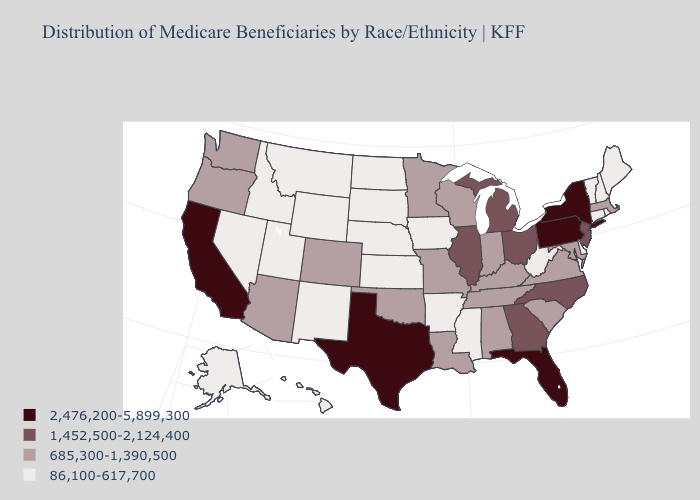Name the states that have a value in the range 86,100-617,700?
Write a very short answer. Alaska, Arkansas, Connecticut, Delaware, Hawaii, Idaho, Iowa, Kansas, Maine, Mississippi, Montana, Nebraska, Nevada, New Hampshire, New Mexico, North Dakota, Rhode Island, South Dakota, Utah, Vermont, West Virginia, Wyoming. Name the states that have a value in the range 2,476,200-5,899,300?
Short answer required. California, Florida, New York, Pennsylvania, Texas. Name the states that have a value in the range 1,452,500-2,124,400?
Short answer required. Georgia, Illinois, Michigan, New Jersey, North Carolina, Ohio. What is the value of New Hampshire?
Be succinct. 86,100-617,700. What is the value of Iowa?
Concise answer only. 86,100-617,700. What is the value of Florida?
Give a very brief answer. 2,476,200-5,899,300. What is the value of Arizona?
Concise answer only. 685,300-1,390,500. Name the states that have a value in the range 86,100-617,700?
Quick response, please. Alaska, Arkansas, Connecticut, Delaware, Hawaii, Idaho, Iowa, Kansas, Maine, Mississippi, Montana, Nebraska, Nevada, New Hampshire, New Mexico, North Dakota, Rhode Island, South Dakota, Utah, Vermont, West Virginia, Wyoming. Does the first symbol in the legend represent the smallest category?
Keep it brief. No. What is the value of Oklahoma?
Quick response, please. 685,300-1,390,500. Name the states that have a value in the range 86,100-617,700?
Be succinct. Alaska, Arkansas, Connecticut, Delaware, Hawaii, Idaho, Iowa, Kansas, Maine, Mississippi, Montana, Nebraska, Nevada, New Hampshire, New Mexico, North Dakota, Rhode Island, South Dakota, Utah, Vermont, West Virginia, Wyoming. Does Washington have the highest value in the USA?
Give a very brief answer. No. What is the lowest value in the South?
Keep it brief. 86,100-617,700. What is the value of Illinois?
Be succinct. 1,452,500-2,124,400. Does the first symbol in the legend represent the smallest category?
Quick response, please. No. 